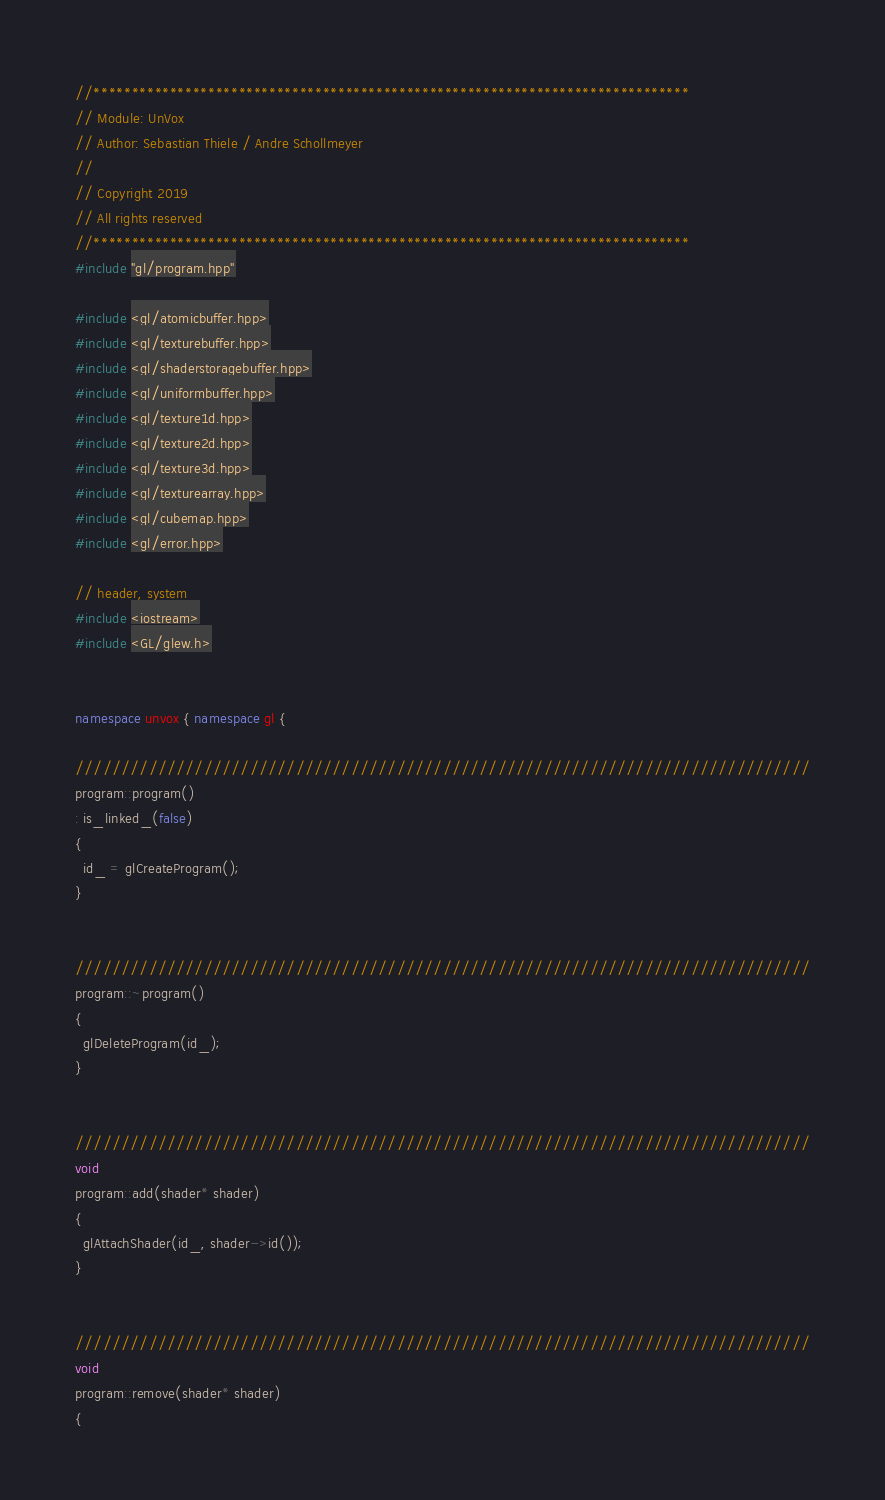<code> <loc_0><loc_0><loc_500><loc_500><_C++_>//******************************************************************************
// Module: UnVox
// Author: Sebastian Thiele / Andre Schollmeyer
// 
// Copyright 2019 
// All rights reserved
//******************************************************************************
#include "gl/program.hpp"

#include <gl/atomicbuffer.hpp>
#include <gl/texturebuffer.hpp>
#include <gl/shaderstoragebuffer.hpp>
#include <gl/uniformbuffer.hpp>
#include <gl/texture1d.hpp>
#include <gl/texture2d.hpp>
#include <gl/texture3d.hpp>
#include <gl/texturearray.hpp>
#include <gl/cubemap.hpp>
#include <gl/error.hpp>

// header, system
#include <iostream>
#include <GL/glew.h>


namespace unvox { namespace gl {

////////////////////////////////////////////////////////////////////////////////
program::program()
: is_linked_(false)
{
  id_ = glCreateProgram();
}


////////////////////////////////////////////////////////////////////////////////
program::~program()
{
  glDeleteProgram(id_);
}


////////////////////////////////////////////////////////////////////////////////
void
program::add(shader* shader)
{
  glAttachShader(id_, shader->id());
}


////////////////////////////////////////////////////////////////////////////////
void
program::remove(shader* shader)
{</code> 